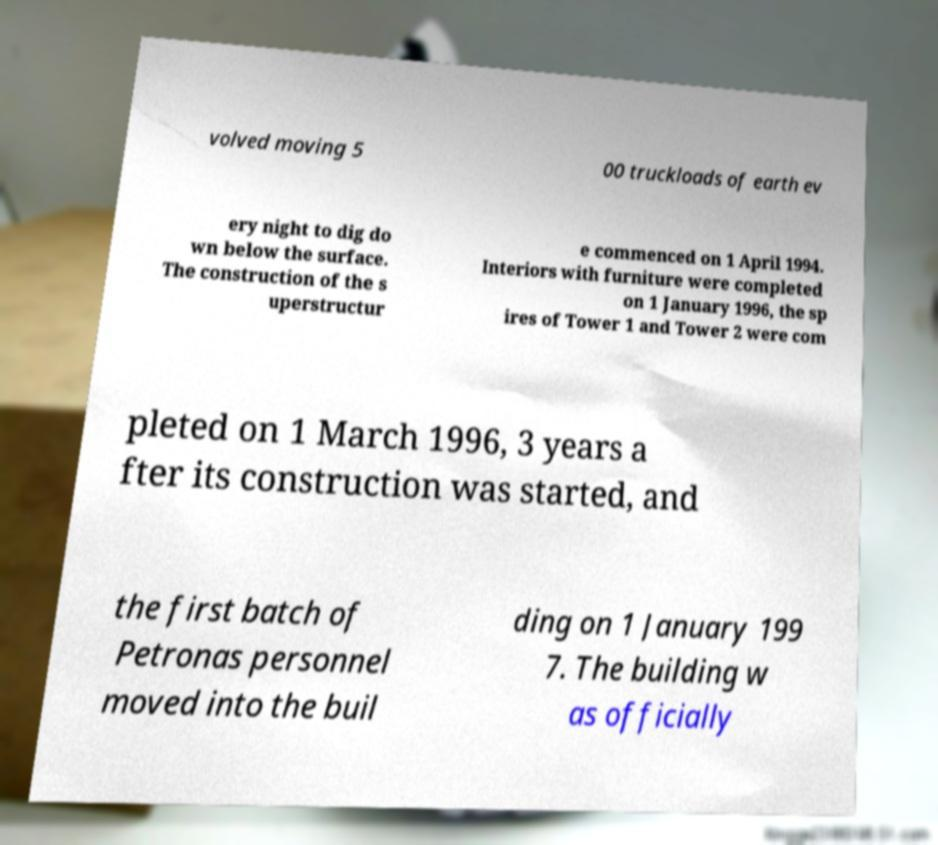Could you assist in decoding the text presented in this image and type it out clearly? volved moving 5 00 truckloads of earth ev ery night to dig do wn below the surface. The construction of the s uperstructur e commenced on 1 April 1994. Interiors with furniture were completed on 1 January 1996, the sp ires of Tower 1 and Tower 2 were com pleted on 1 March 1996, 3 years a fter its construction was started, and the first batch of Petronas personnel moved into the buil ding on 1 January 199 7. The building w as officially 